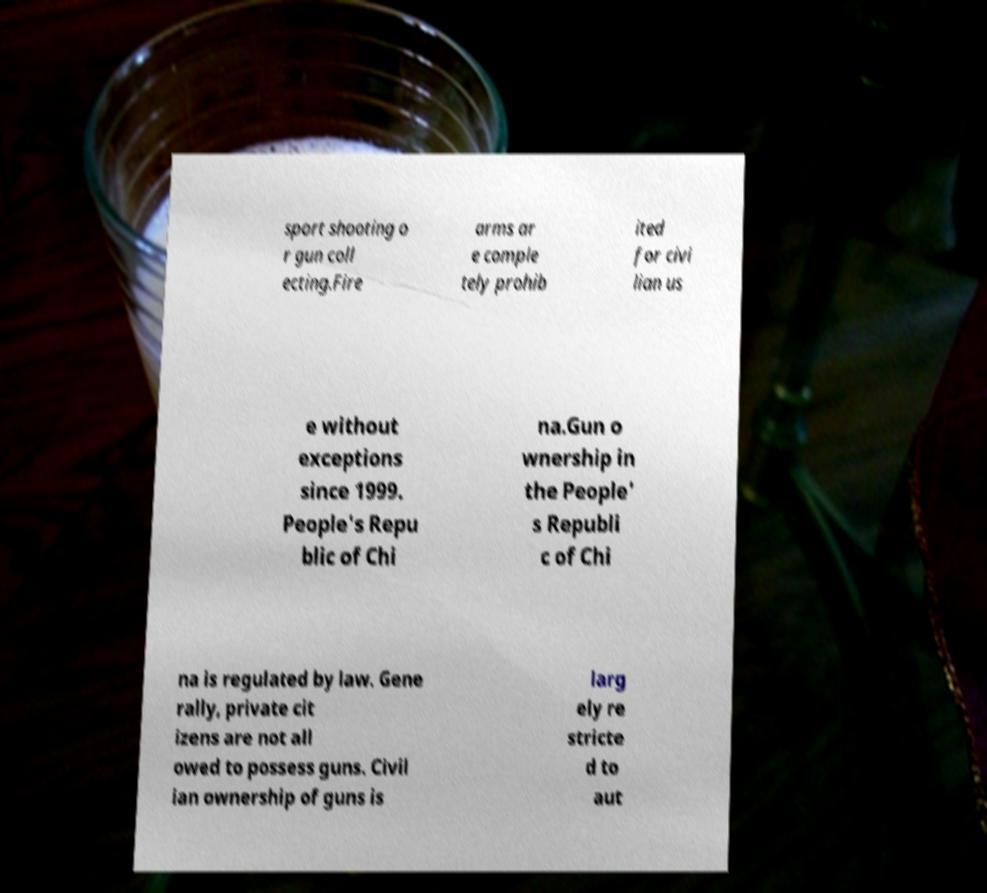Could you assist in decoding the text presented in this image and type it out clearly? sport shooting o r gun coll ecting.Fire arms ar e comple tely prohib ited for civi lian us e without exceptions since 1999. People's Repu blic of Chi na.Gun o wnership in the People' s Republi c of Chi na is regulated by law. Gene rally, private cit izens are not all owed to possess guns. Civil ian ownership of guns is larg ely re stricte d to aut 